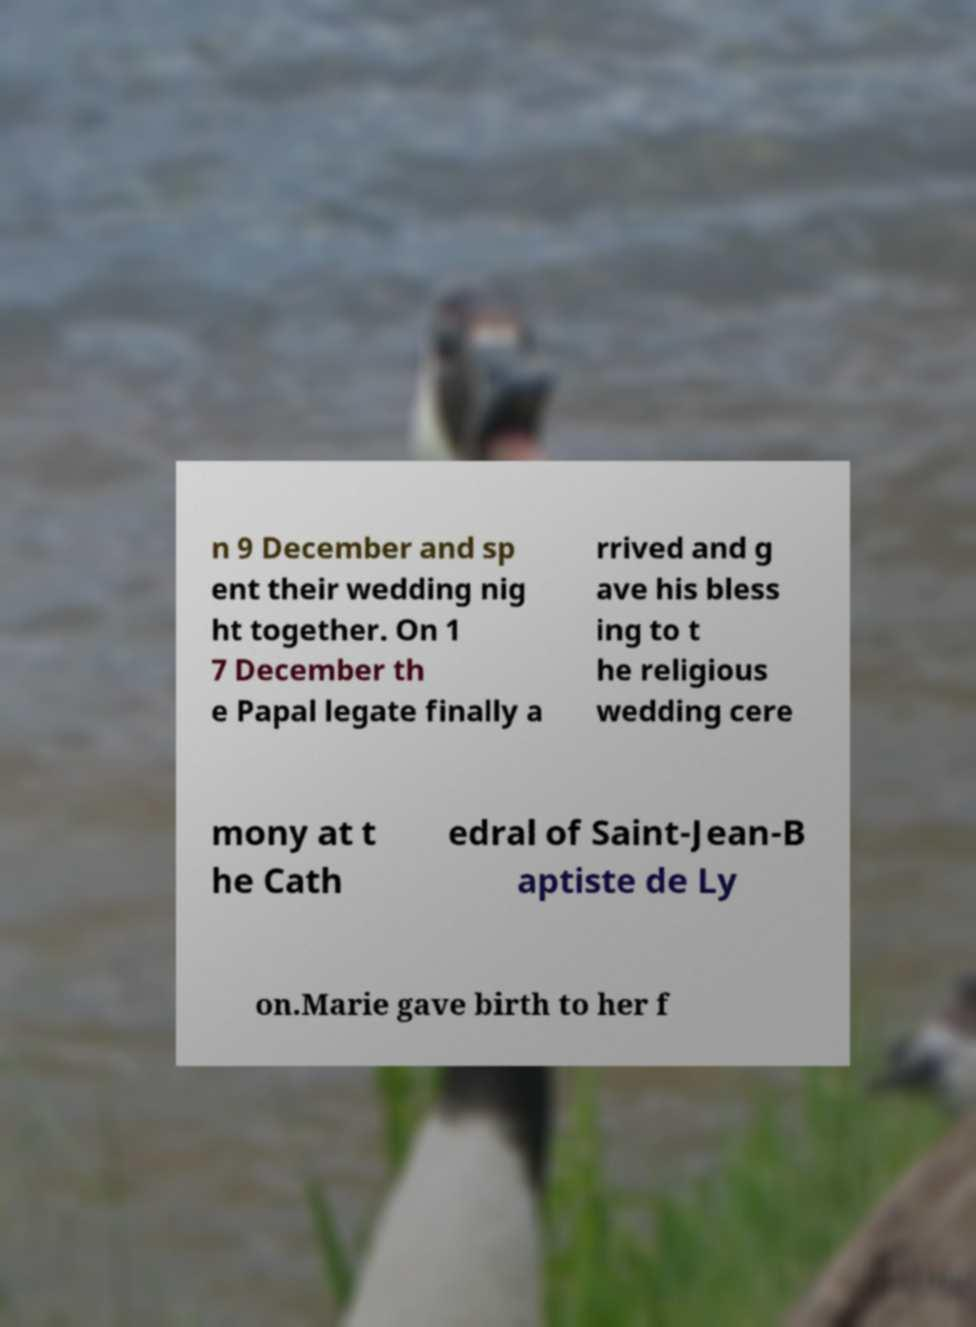Could you assist in decoding the text presented in this image and type it out clearly? n 9 December and sp ent their wedding nig ht together. On 1 7 December th e Papal legate finally a rrived and g ave his bless ing to t he religious wedding cere mony at t he Cath edral of Saint-Jean-B aptiste de Ly on.Marie gave birth to her f 